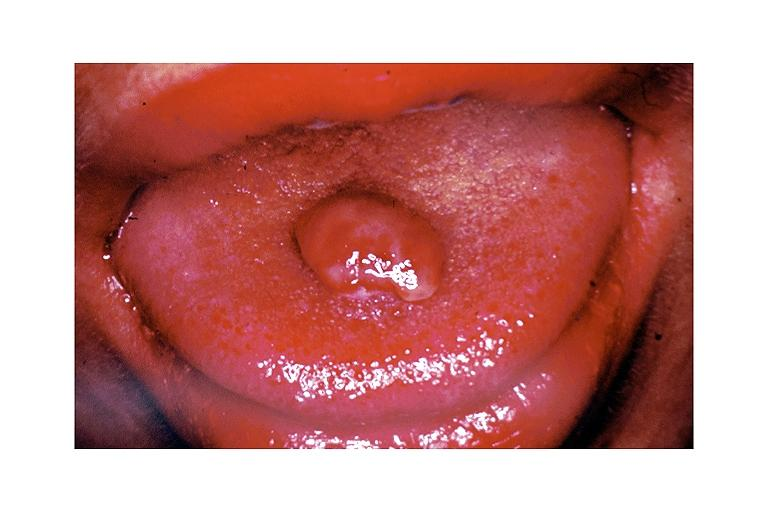s oral present?
Answer the question using a single word or phrase. Yes 